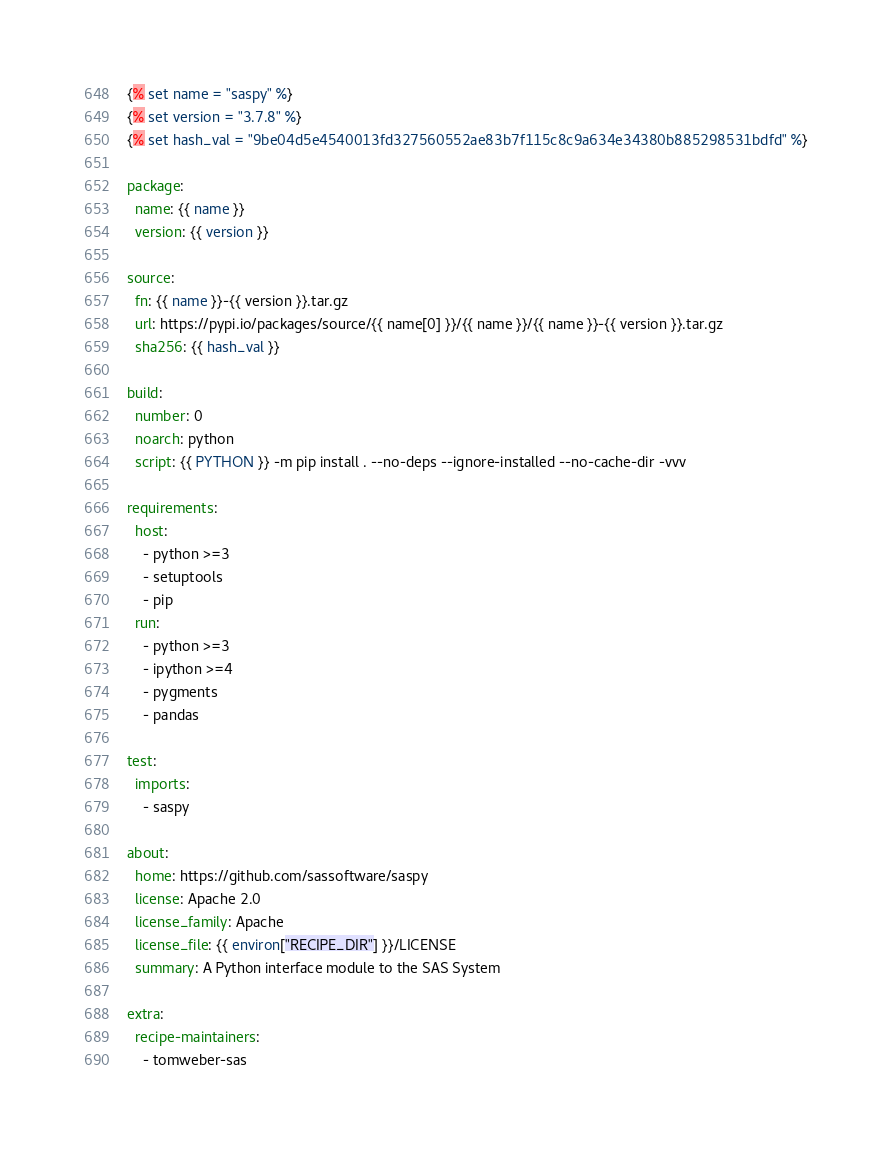<code> <loc_0><loc_0><loc_500><loc_500><_YAML_>{% set name = "saspy" %}
{% set version = "3.7.8" %}
{% set hash_val = "9be04d5e4540013fd327560552ae83b7f115c8c9a634e34380b885298531bdfd" %}

package:
  name: {{ name }}
  version: {{ version }}

source:
  fn: {{ name }}-{{ version }}.tar.gz
  url: https://pypi.io/packages/source/{{ name[0] }}/{{ name }}/{{ name }}-{{ version }}.tar.gz
  sha256: {{ hash_val }}

build:
  number: 0
  noarch: python
  script: {{ PYTHON }} -m pip install . --no-deps --ignore-installed --no-cache-dir -vvv

requirements:
  host:
    - python >=3
    - setuptools
    - pip
  run:
    - python >=3
    - ipython >=4
    - pygments
    - pandas

test:
  imports:
    - saspy

about:
  home: https://github.com/sassoftware/saspy
  license: Apache 2.0
  license_family: Apache
  license_file: {{ environ["RECIPE_DIR"] }}/LICENSE
  summary: A Python interface module to the SAS System

extra:
  recipe-maintainers:
    - tomweber-sas
</code> 